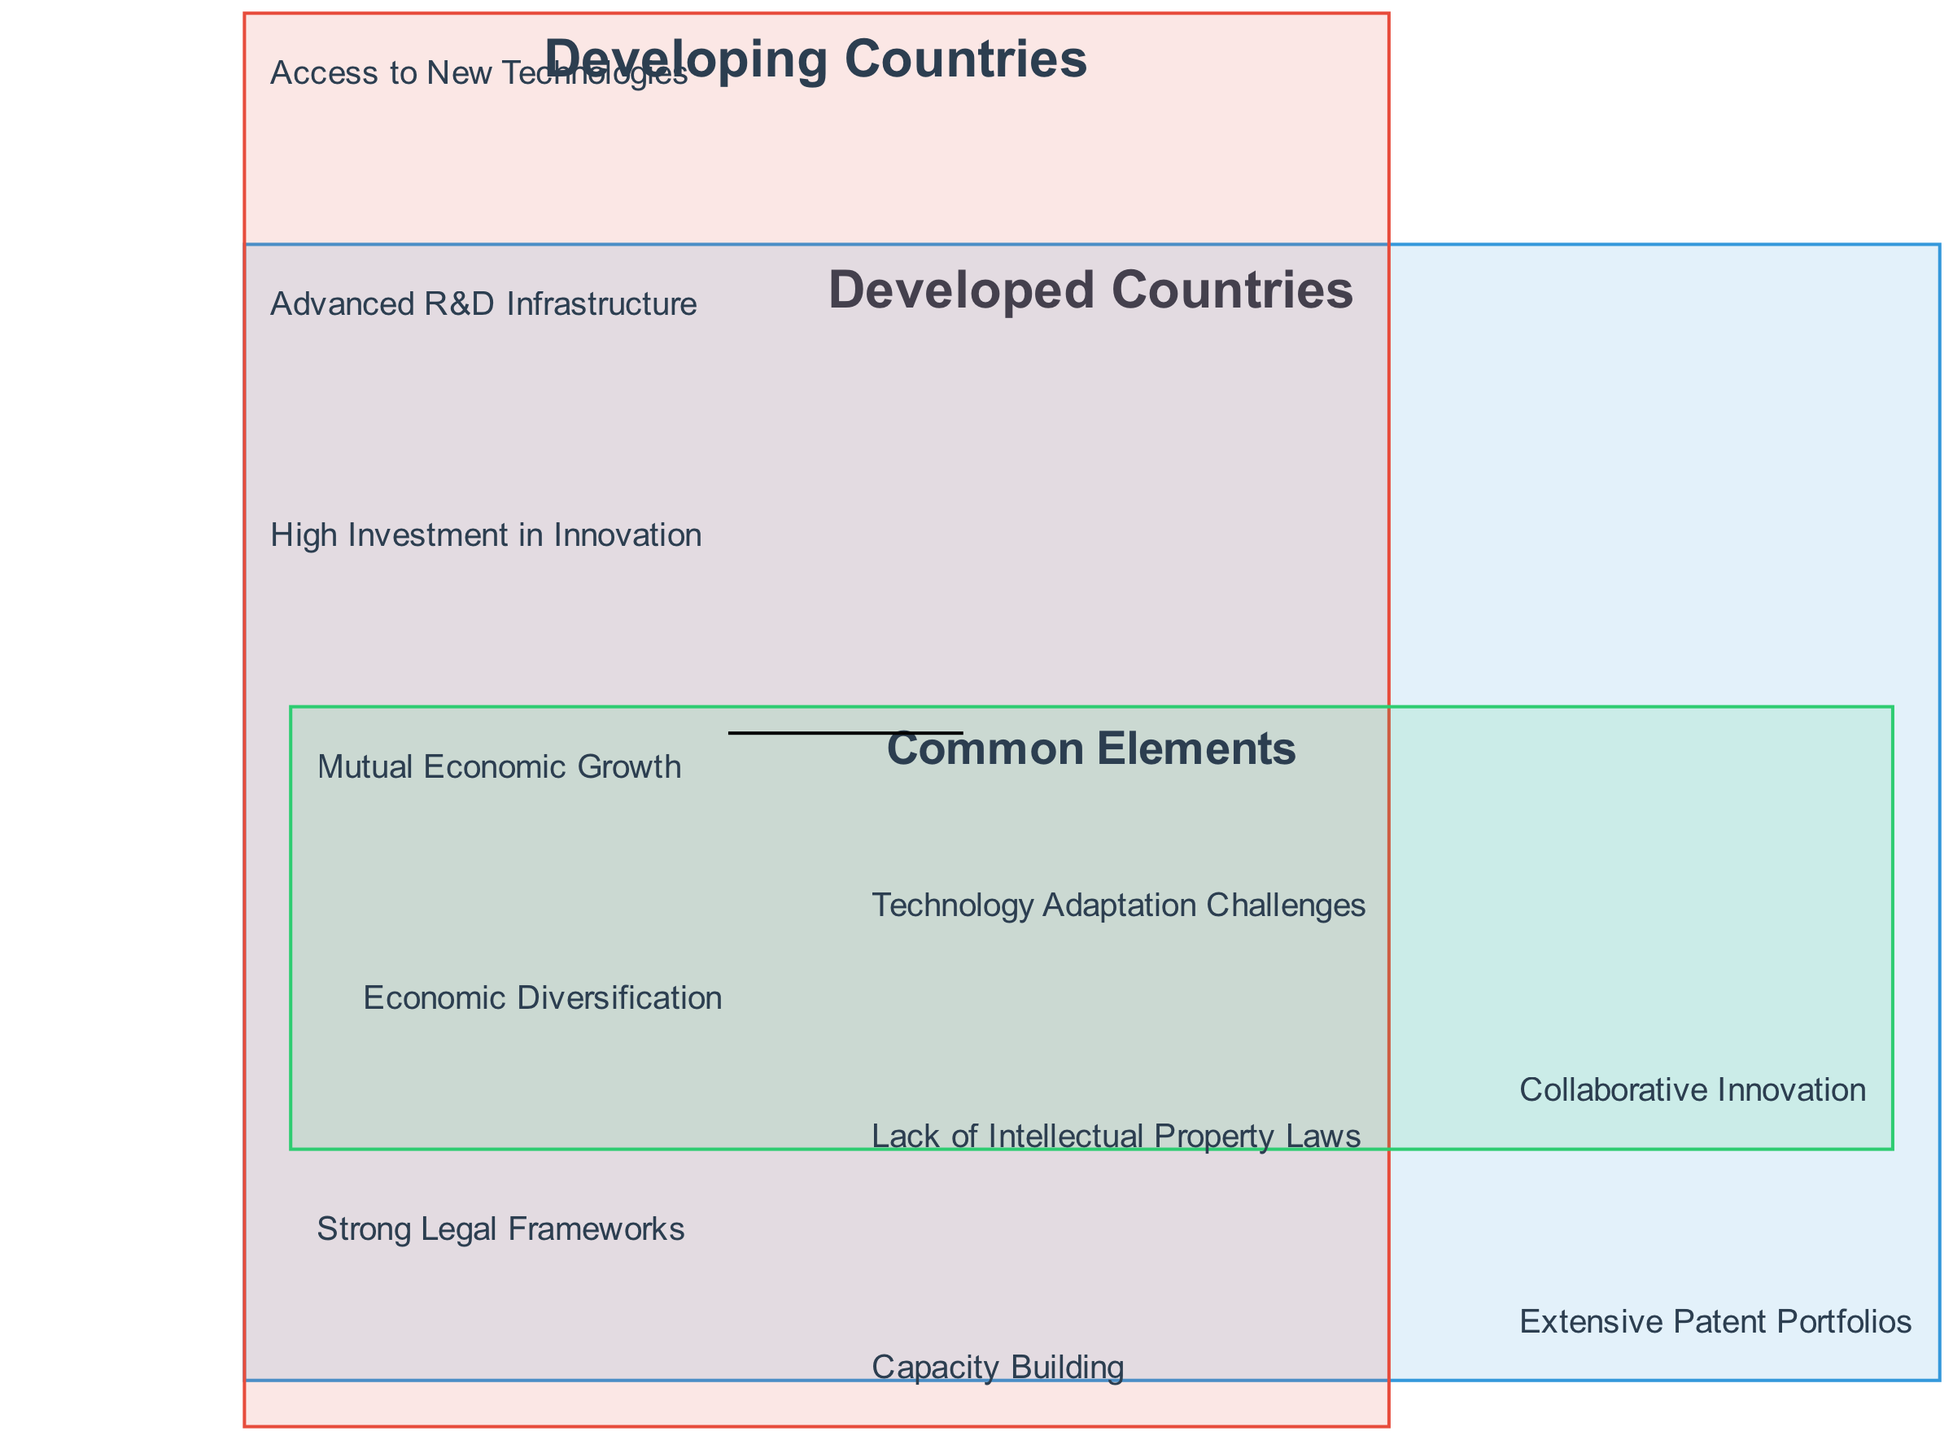What elements are in the circle labeled "Developed Countries"? The circle labeled "Developed Countries" contains four elements: "Advanced R&D Infrastructure," "High Investment in Innovation," "Extensive Patent Portfolios," and "Strong Legal Frameworks." These elements can be directly observed in that specific circle of the diagram.
Answer: Advanced R&D Infrastructure, High Investment in Innovation, Extensive Patent Portfolios, Strong Legal Frameworks What is one benefit common to both developed and developing countries? The common elements section of the diagram lists "Mutual Economic Growth," "Collaborative Innovation," and "Technology Adaptation Challenges." These elements represent benefits that both developed and developing countries can experience.
Answer: Mutual Economic Growth How many elements are listed under "Developing Countries"? The "Developing Countries" circle includes four elements: "Access to New Technologies," "Capacity Building," "Economic Diversification," and "Lack of Intellectual Property Laws." By counting these items in the circle, I can determine the total.
Answer: 4 Which element indicates a challenge in technology adaptation? The element "Technology Adaptation Challenges" is specifically listed in the overlap section of the diagram, indicating that it is a recognized challenge affecting both developed and developing countries during technology transfer.
Answer: Technology Adaptation Challenges How are "High Investment in Innovation" and "Access to New Technologies" related? "High Investment in Innovation" belongs to the developed countries, while "Access to New Technologies" is under developing countries. The relationship shows that a high investment in innovation by developed countries can facilitate access to new technologies for developing countries, highlighting a crucial link between these two elements in the context of technology transfer.
Answer: They are linked through technology transfer Which country type has "Lack of Intellectual Property Laws" as a challenge? The "Lack of Intellectual Property Laws" element is found in the "Developing Countries" circle, indicating that it is a specific challenge faced by those countries in the context of technology transfer.
Answer: Developing Countries 